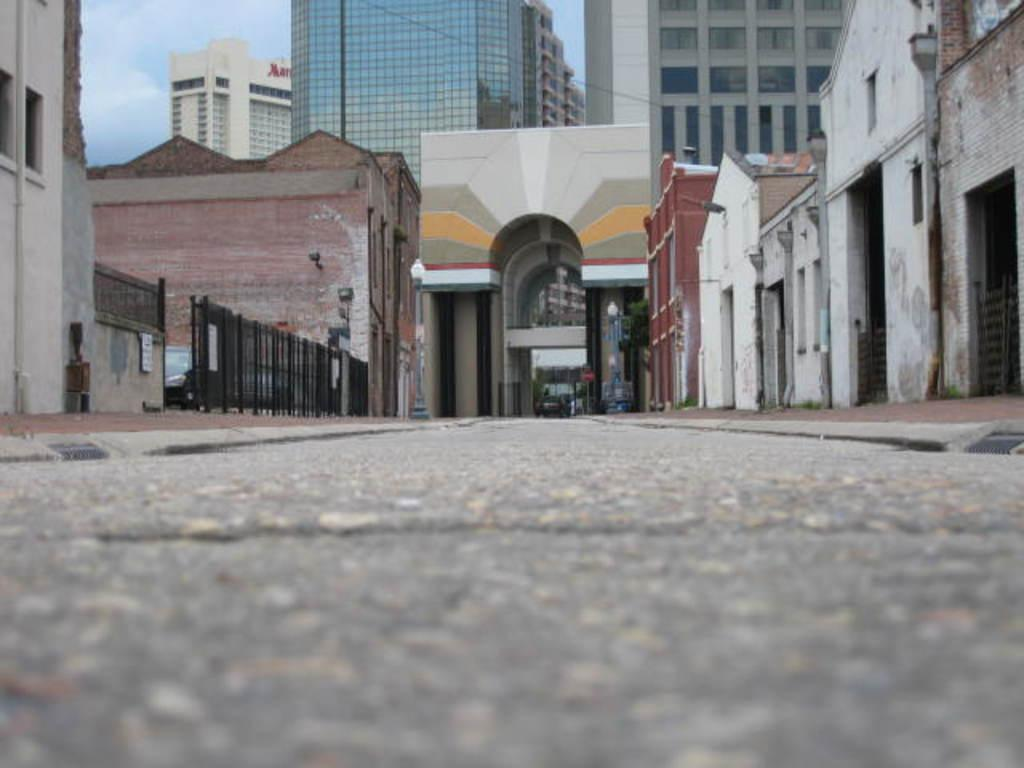What is the main feature of the image? There is a road in the image. What is on the road? There is a car on the road. What type of structures can be seen in the image? There are houses, a fence, poles, lights, and buildings in the image. What can be seen in the background of the image? The sky is visible in the background of the image. What letters are being delivered by the smoke in the image? There is no smoke or letters present in the image. What type of box is being carried by the car in the image? There is no box visible in the image; only a car is present on the road. 